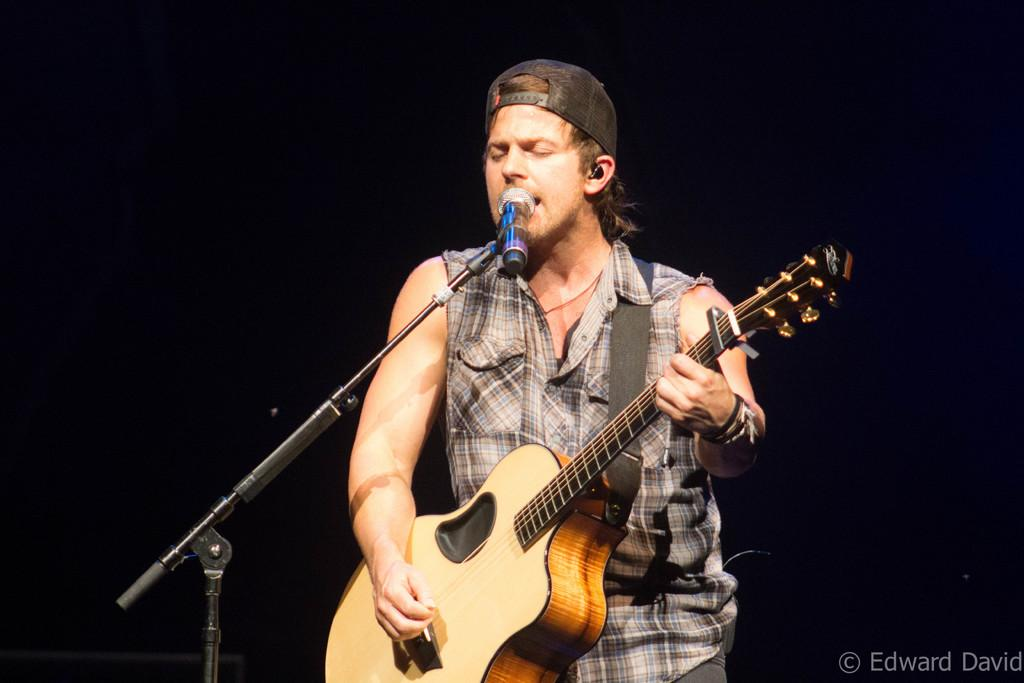What is the main subject of the image? There is a person in the image. What can be observed about the person's attire? The person is wearing clothes and a cap. What is the person doing in the image? The person is standing in front of a microphone and playing a guitar. How many icicles are hanging from the person's cap in the image? There are no icicles present in the image. What organization does the person represent in the image? The image does not provide any information about the person's affiliation with an organization. 